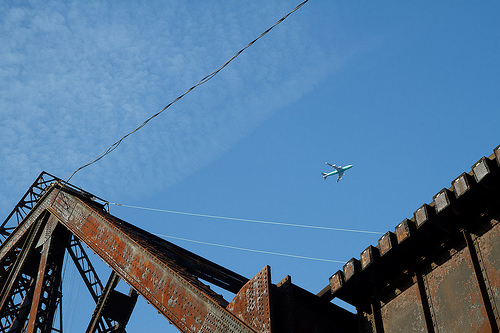Please provide a short description for this region: [0.42, 0.31, 0.62, 0.46]. A picturesque scene of white clouds in a bright blue sky. 